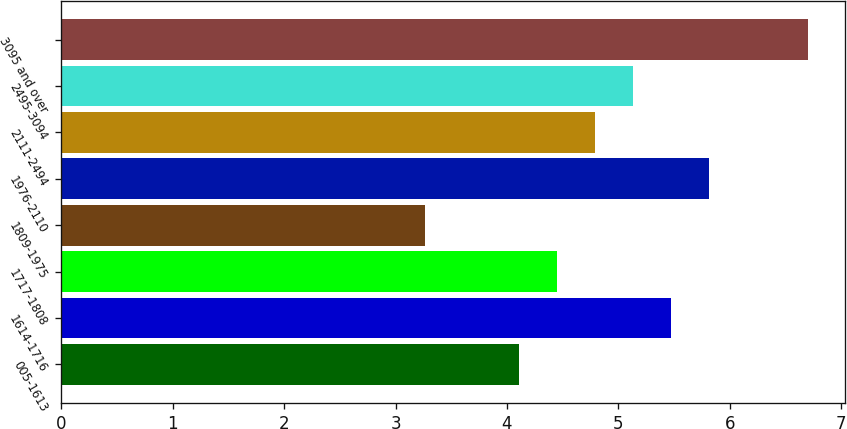Convert chart. <chart><loc_0><loc_0><loc_500><loc_500><bar_chart><fcel>005-1613<fcel>1614-1716<fcel>1717-1808<fcel>1809-1975<fcel>1976-2110<fcel>2111-2494<fcel>2495-3094<fcel>3095 and over<nl><fcel>4.11<fcel>5.47<fcel>4.45<fcel>3.26<fcel>5.81<fcel>4.79<fcel>5.13<fcel>6.7<nl></chart> 